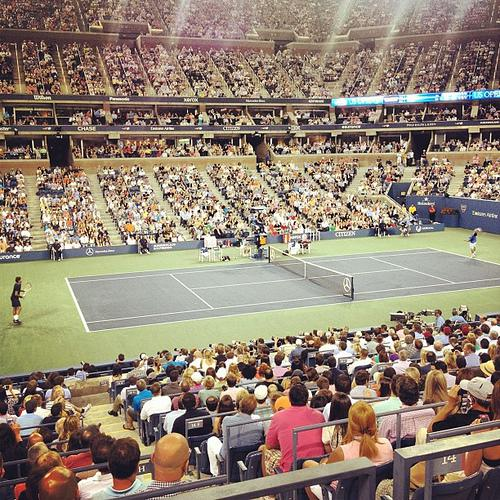Question: where was the photo taken?
Choices:
A. A raquetball court.
B. A tennis stadium.
C. A football stadium.
D. A rodeo arena.
Answer with the letter. Answer: B Question: where are the fans?
Choices:
A. In windows.
B. On floor.
C. Beside the road.
D. Stands.
Answer with the letter. Answer: D Question: where are the white lines?
Choices:
A. On football field.
B. Tennis court.
C. On road.
D. On track.
Answer with the letter. Answer: B Question: how many people have tennis rackets?
Choices:
A. Three.
B. Four.
C. Two.
D. Five.
Answer with the letter. Answer: C Question: what is in the middle of the tennis court?
Choices:
A. White line.
B. Ball boy.
C. Coach.
D. Net.
Answer with the letter. Answer: D 